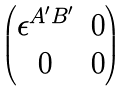<formula> <loc_0><loc_0><loc_500><loc_500>\begin{pmatrix} \epsilon ^ { A ^ { \prime } B ^ { \prime } } & 0 \\ 0 & 0 \end{pmatrix}</formula> 